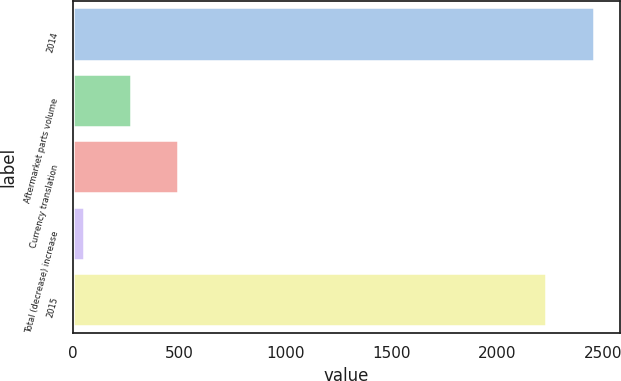Convert chart. <chart><loc_0><loc_0><loc_500><loc_500><bar_chart><fcel>2014<fcel>Aftermarket parts volume<fcel>Currency translation<fcel>Total (decrease) increase<fcel>2015<nl><fcel>2455.64<fcel>272.54<fcel>495.78<fcel>49.3<fcel>2232.4<nl></chart> 